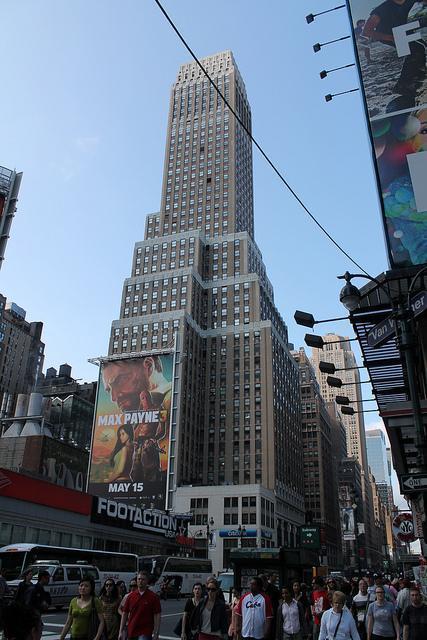How many tiers does the building have?
Give a very brief answer. 4. How many people are there?
Give a very brief answer. 2. 